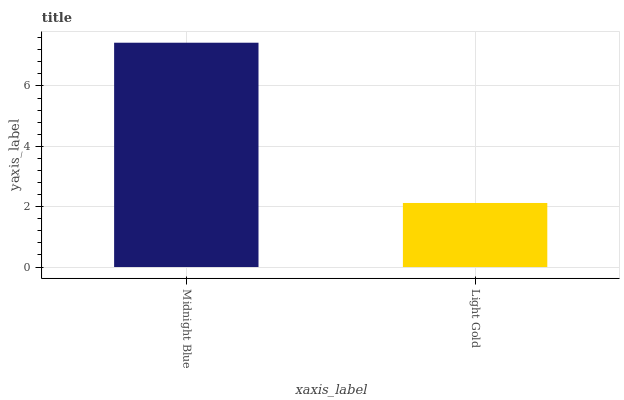Is Light Gold the minimum?
Answer yes or no. Yes. Is Midnight Blue the maximum?
Answer yes or no. Yes. Is Light Gold the maximum?
Answer yes or no. No. Is Midnight Blue greater than Light Gold?
Answer yes or no. Yes. Is Light Gold less than Midnight Blue?
Answer yes or no. Yes. Is Light Gold greater than Midnight Blue?
Answer yes or no. No. Is Midnight Blue less than Light Gold?
Answer yes or no. No. Is Midnight Blue the high median?
Answer yes or no. Yes. Is Light Gold the low median?
Answer yes or no. Yes. Is Light Gold the high median?
Answer yes or no. No. Is Midnight Blue the low median?
Answer yes or no. No. 